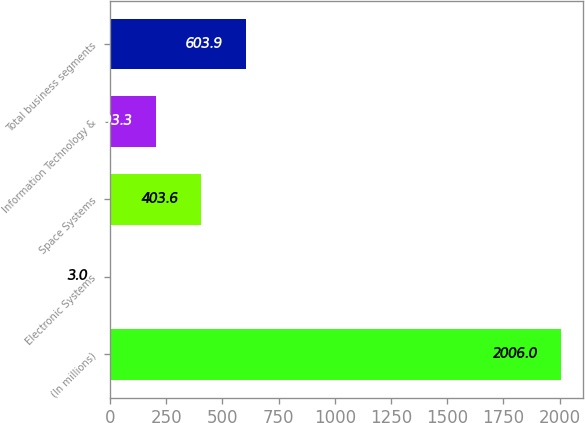Convert chart. <chart><loc_0><loc_0><loc_500><loc_500><bar_chart><fcel>(In millions)<fcel>Electronic Systems<fcel>Space Systems<fcel>Information Technology &<fcel>Total business segments<nl><fcel>2006<fcel>3<fcel>403.6<fcel>203.3<fcel>603.9<nl></chart> 